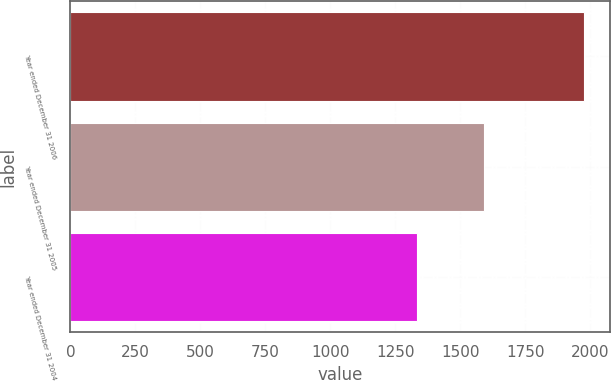Convert chart. <chart><loc_0><loc_0><loc_500><loc_500><bar_chart><fcel>Year ended December 31 2006<fcel>Year ended December 31 2005<fcel>Year ended December 31 2004<nl><fcel>1978<fcel>1591<fcel>1334<nl></chart> 